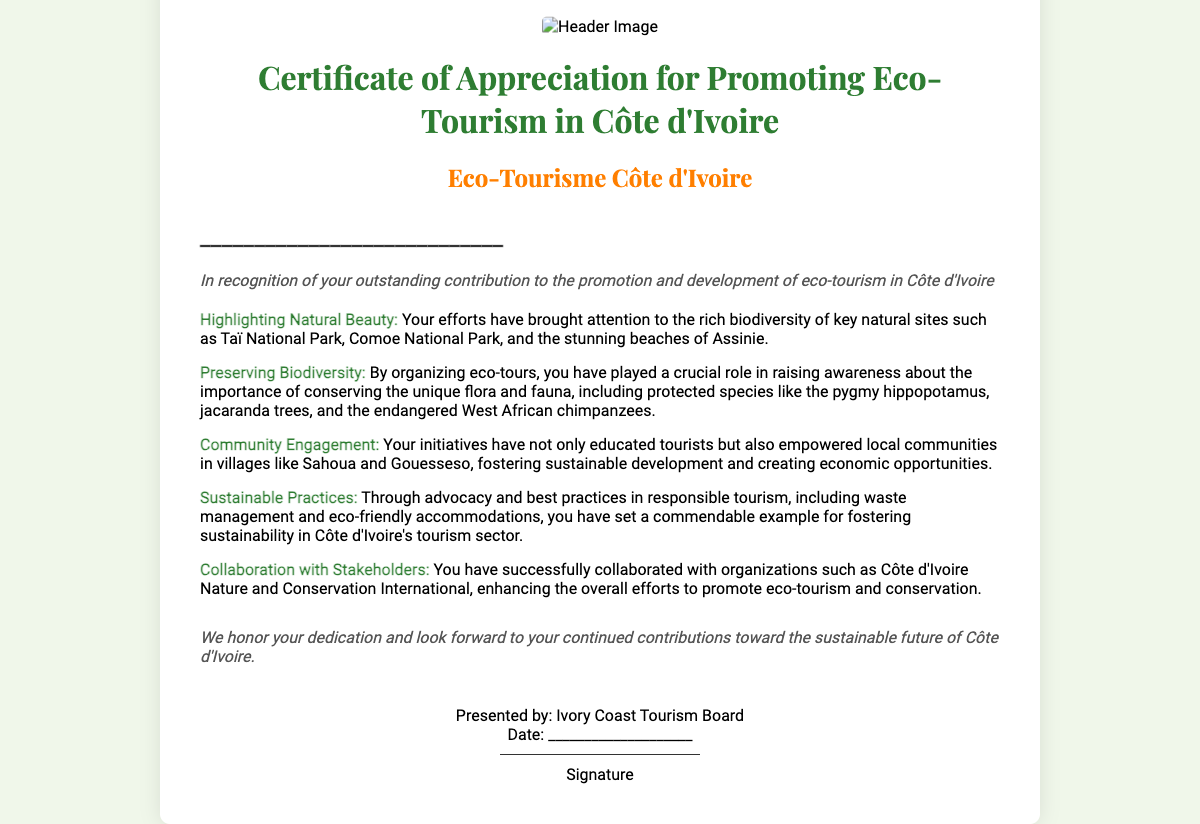What is the title of the certificate? The title appears prominently at the top of the document and states the purpose of the certificate.
Answer: Certificate of Appreciation for Promoting Eco-Tourism in Côte d'Ivoire Who presented the certificate? The entity responsible for presenting the certificate is mentioned at the bottom of the document.
Answer: Ivory Coast Tourism Board What is the date section for? There is a section in the footer designated for recording the date of issuance of the certificate.
Answer: Date: ____________________ What is one of the key natural sites highlighted in the certificate? The document mentions specific natural sites that were promoted through eco-tours.
Answer: Taï National Park How does the certificate define sustainable practices? The document includes a section discussing responsible tourism practices that contribute to sustainability.
Answer: Advocacy and best practices in responsible tourism What does the recipient receive recognition for? The document states the reason for the certificate directly in the greeting section.
Answer: Outstanding contribution to the promotion and development of eco-tourism What role did community engagement play according to the certificate? The content discusses community involvement and the impact of eco-tours on local populations.
Answer: Empowered local communities What is emphasized about collaboration with organizations? The certificate outlines collaborative efforts that enhance eco-tourism promotion and conservation.
Answer: Successfully collaborated with organizations 